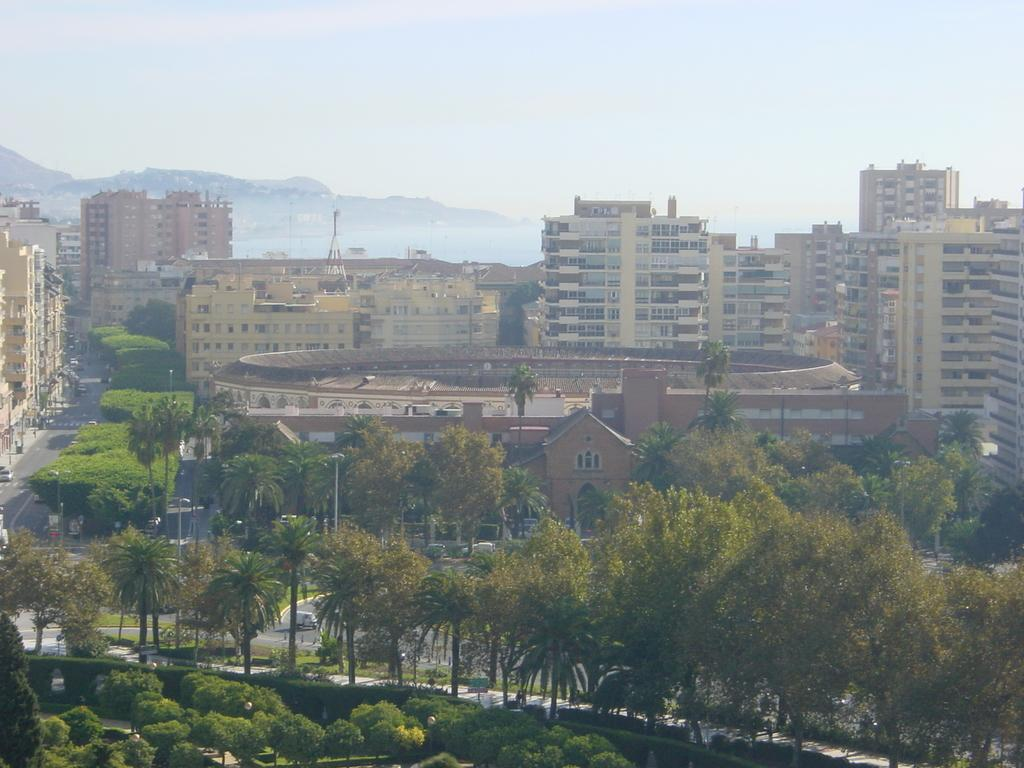What can be seen in the center of the image? The sky is visible in the center of the image. What type of natural landscape is present in the image? There are hills in the image. What type of man-made structures can be seen in the image? There are buildings in the image. What type of vegetation is present in the image? Trees are present in the image. What type of transportation is visible in the image? Vehicles are on the road in the image. What type of vertical structures are visible in the image? Poles are visible in the image. What other objects can be seen in the image? There are a few other objects in the image. What type of crime is being committed in the image? There is no indication of any crime being committed in the image. Can you tell me how many trains are visible in the image? There are no trains present in the image. 